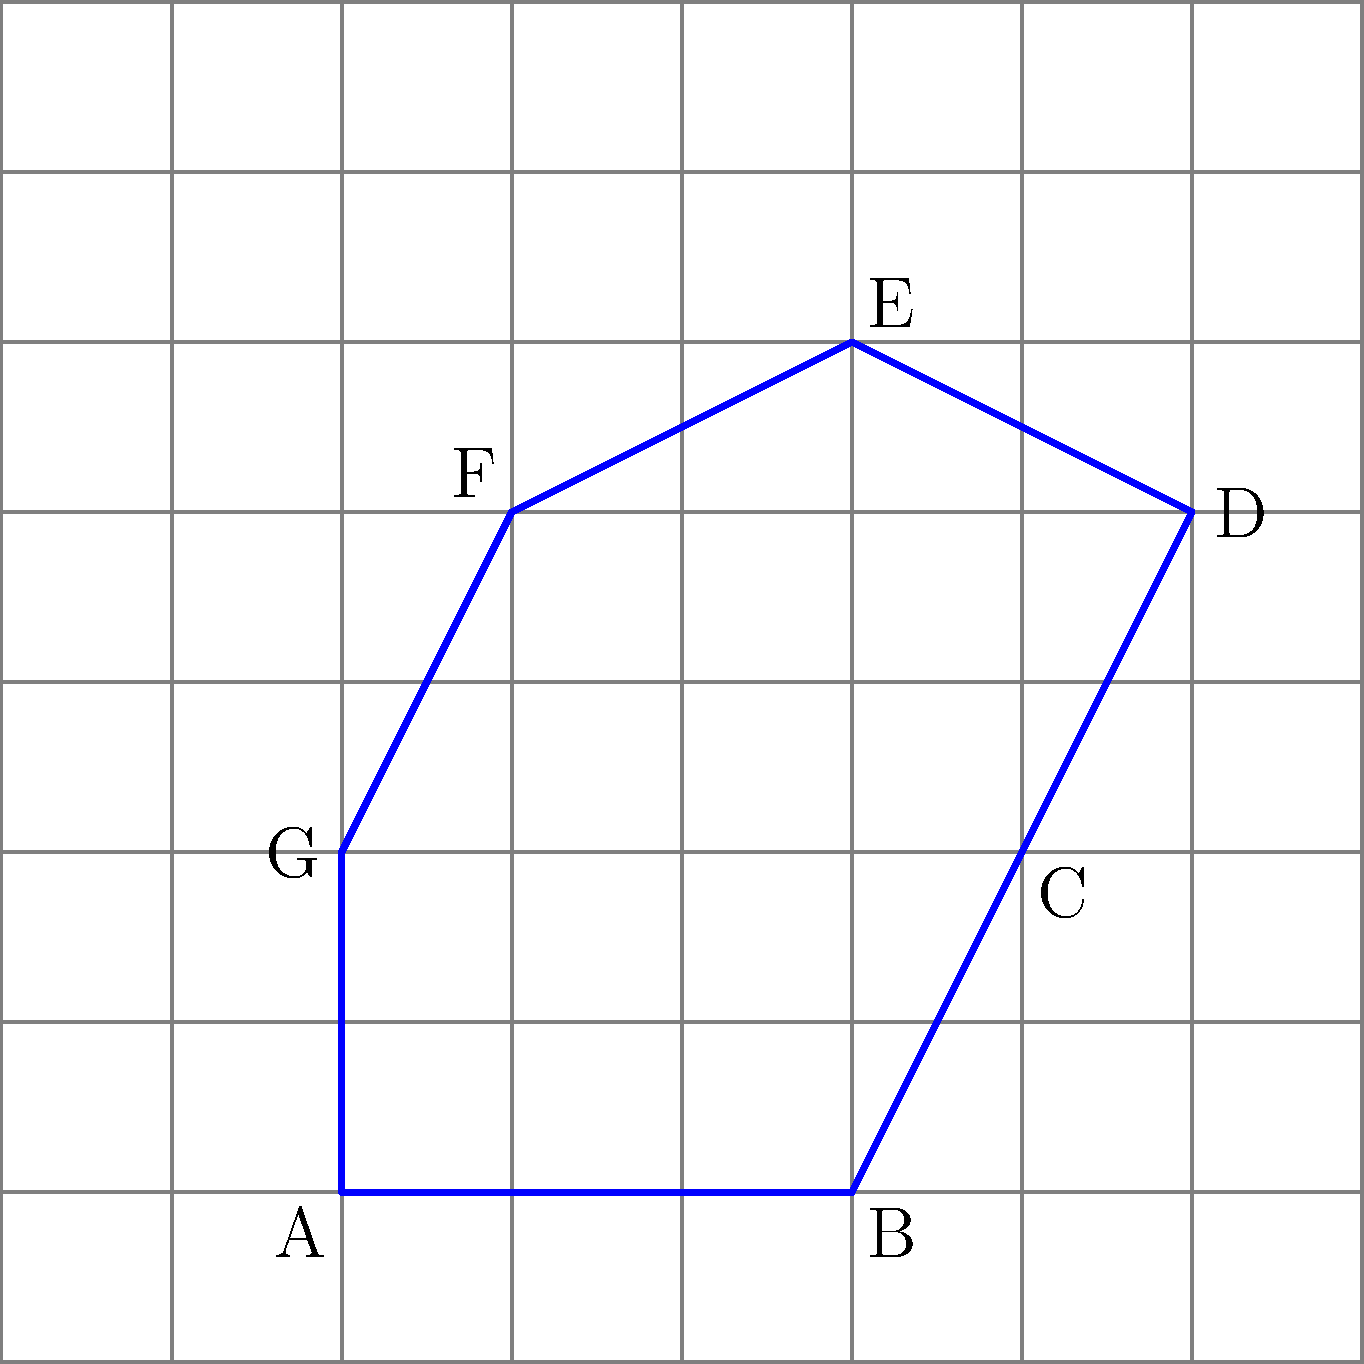A polygon is drawn on a grid where each square represents 1 unit. Calculate the perimeter of the polygon shown in the figure. Round your answer to the nearest whole number if necessary. To calculate the perimeter of the irregular polygon, we need to sum up the lengths of all its sides. Let's go through this step-by-step:

1) First, let's identify each side of the polygon:
   AB, BC, CD, DE, EF, FG, and GA

2) Now, let's calculate the length of each side using the distance formula:
   $d = \sqrt{(x_2-x_1)^2 + (y_2-y_1)^2}$

   AB: $\sqrt{(5-2)^2 + (1-1)^2} = 3$
   BC: $\sqrt{(6-5)^2 + (3-1)^2} = \sqrt{5}$
   CD: $\sqrt{(7-6)^2 + (5-3)^2} = \sqrt{5}$
   DE: $\sqrt{(5-7)^2 + (6-5)^2} = \sqrt{5}$
   EF: $\sqrt{(3-5)^2 + (5-6)^2} = \sqrt{5}$
   FG: $\sqrt{(2-3)^2 + (3-5)^2} = \sqrt{5}$
   GA: $\sqrt{(2-2)^2 + (1-3)^2} = 2$

3) Now, let's sum up all these lengths:
   $3 + \sqrt{5} + \sqrt{5} + \sqrt{5} + \sqrt{5} + \sqrt{5} + 2$

4) Simplify:
   $5 + 5\sqrt{5}$

5) To get a decimal approximation:
   $5 + 5\sqrt{5} \approx 5 + 5(2.236) = 16.18$

6) Rounding to the nearest whole number:
   16.18 ≈ 16

Therefore, the perimeter of the polygon is approximately 16 units.
Answer: 16 units 